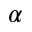Convert formula to latex. <formula><loc_0><loc_0><loc_500><loc_500>\alpha</formula> 